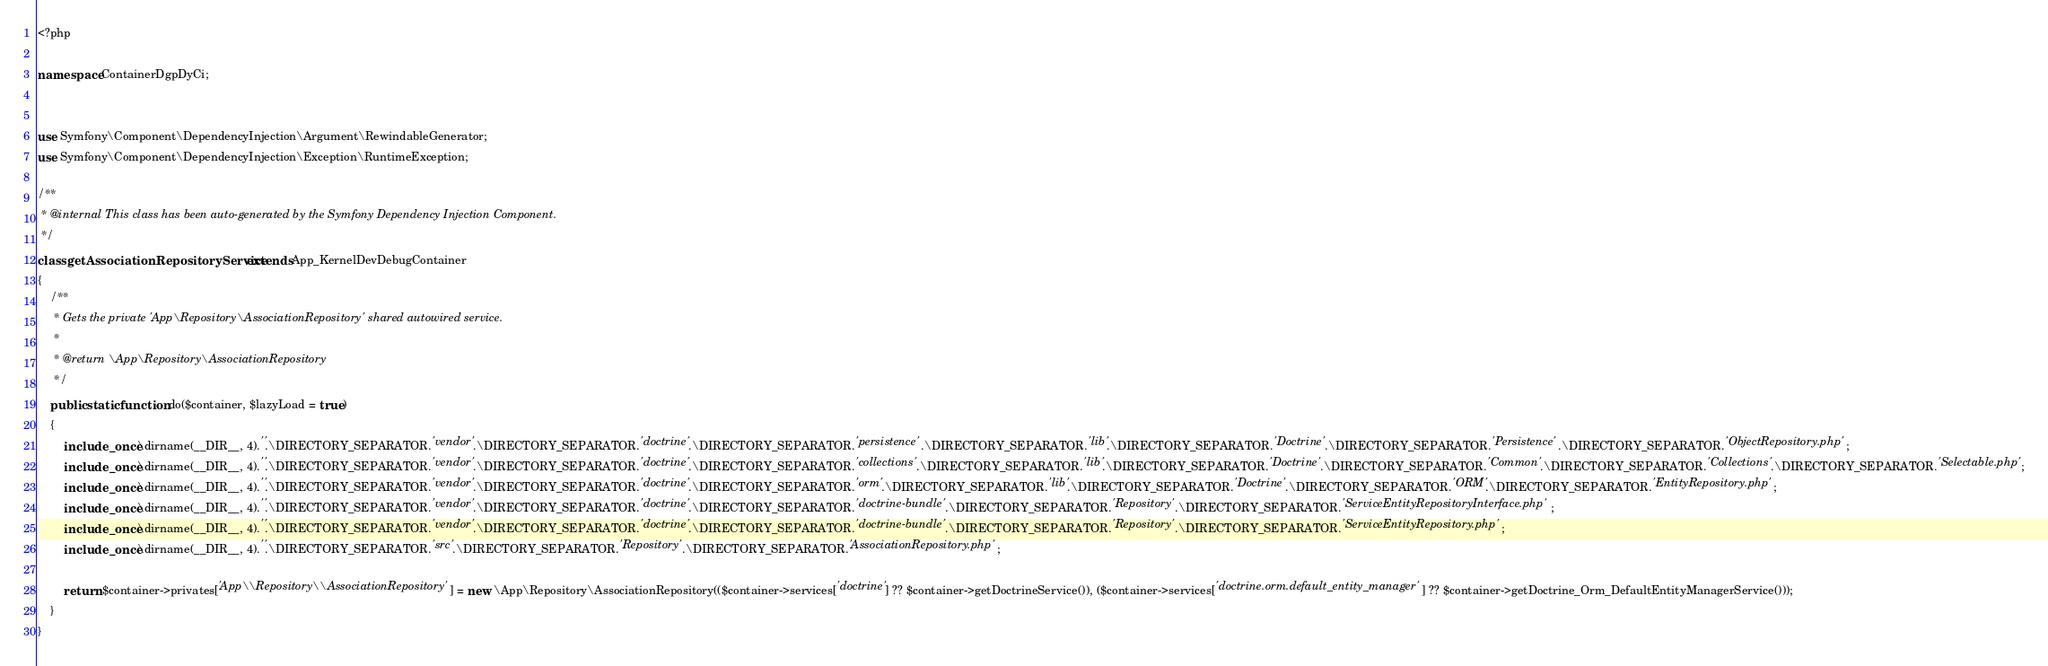<code> <loc_0><loc_0><loc_500><loc_500><_PHP_><?php

namespace ContainerDgpDyCi;


use Symfony\Component\DependencyInjection\Argument\RewindableGenerator;
use Symfony\Component\DependencyInjection\Exception\RuntimeException;

/**
 * @internal This class has been auto-generated by the Symfony Dependency Injection Component.
 */
class getAssociationRepositoryService extends App_KernelDevDebugContainer
{
    /**
     * Gets the private 'App\Repository\AssociationRepository' shared autowired service.
     *
     * @return \App\Repository\AssociationRepository
     */
    public static function do($container, $lazyLoad = true)
    {
        include_once \dirname(__DIR__, 4).''.\DIRECTORY_SEPARATOR.'vendor'.\DIRECTORY_SEPARATOR.'doctrine'.\DIRECTORY_SEPARATOR.'persistence'.\DIRECTORY_SEPARATOR.'lib'.\DIRECTORY_SEPARATOR.'Doctrine'.\DIRECTORY_SEPARATOR.'Persistence'.\DIRECTORY_SEPARATOR.'ObjectRepository.php';
        include_once \dirname(__DIR__, 4).''.\DIRECTORY_SEPARATOR.'vendor'.\DIRECTORY_SEPARATOR.'doctrine'.\DIRECTORY_SEPARATOR.'collections'.\DIRECTORY_SEPARATOR.'lib'.\DIRECTORY_SEPARATOR.'Doctrine'.\DIRECTORY_SEPARATOR.'Common'.\DIRECTORY_SEPARATOR.'Collections'.\DIRECTORY_SEPARATOR.'Selectable.php';
        include_once \dirname(__DIR__, 4).''.\DIRECTORY_SEPARATOR.'vendor'.\DIRECTORY_SEPARATOR.'doctrine'.\DIRECTORY_SEPARATOR.'orm'.\DIRECTORY_SEPARATOR.'lib'.\DIRECTORY_SEPARATOR.'Doctrine'.\DIRECTORY_SEPARATOR.'ORM'.\DIRECTORY_SEPARATOR.'EntityRepository.php';
        include_once \dirname(__DIR__, 4).''.\DIRECTORY_SEPARATOR.'vendor'.\DIRECTORY_SEPARATOR.'doctrine'.\DIRECTORY_SEPARATOR.'doctrine-bundle'.\DIRECTORY_SEPARATOR.'Repository'.\DIRECTORY_SEPARATOR.'ServiceEntityRepositoryInterface.php';
        include_once \dirname(__DIR__, 4).''.\DIRECTORY_SEPARATOR.'vendor'.\DIRECTORY_SEPARATOR.'doctrine'.\DIRECTORY_SEPARATOR.'doctrine-bundle'.\DIRECTORY_SEPARATOR.'Repository'.\DIRECTORY_SEPARATOR.'ServiceEntityRepository.php';
        include_once \dirname(__DIR__, 4).''.\DIRECTORY_SEPARATOR.'src'.\DIRECTORY_SEPARATOR.'Repository'.\DIRECTORY_SEPARATOR.'AssociationRepository.php';

        return $container->privates['App\\Repository\\AssociationRepository'] = new \App\Repository\AssociationRepository(($container->services['doctrine'] ?? $container->getDoctrineService()), ($container->services['doctrine.orm.default_entity_manager'] ?? $container->getDoctrine_Orm_DefaultEntityManagerService()));
    }
}
</code> 